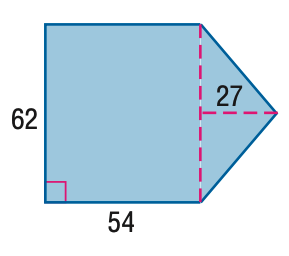Question: Find the area of the figure. Round to the nearest tenth if necessary.
Choices:
A. 2511
B. 3348
C. 4185
D. 5022
Answer with the letter. Answer: C 